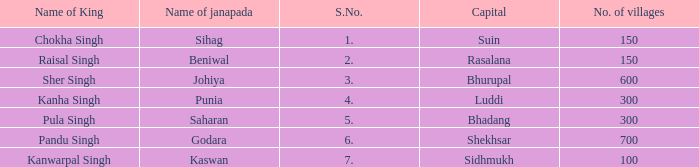What is the highest S number with a capital of Shekhsar? 6.0. 